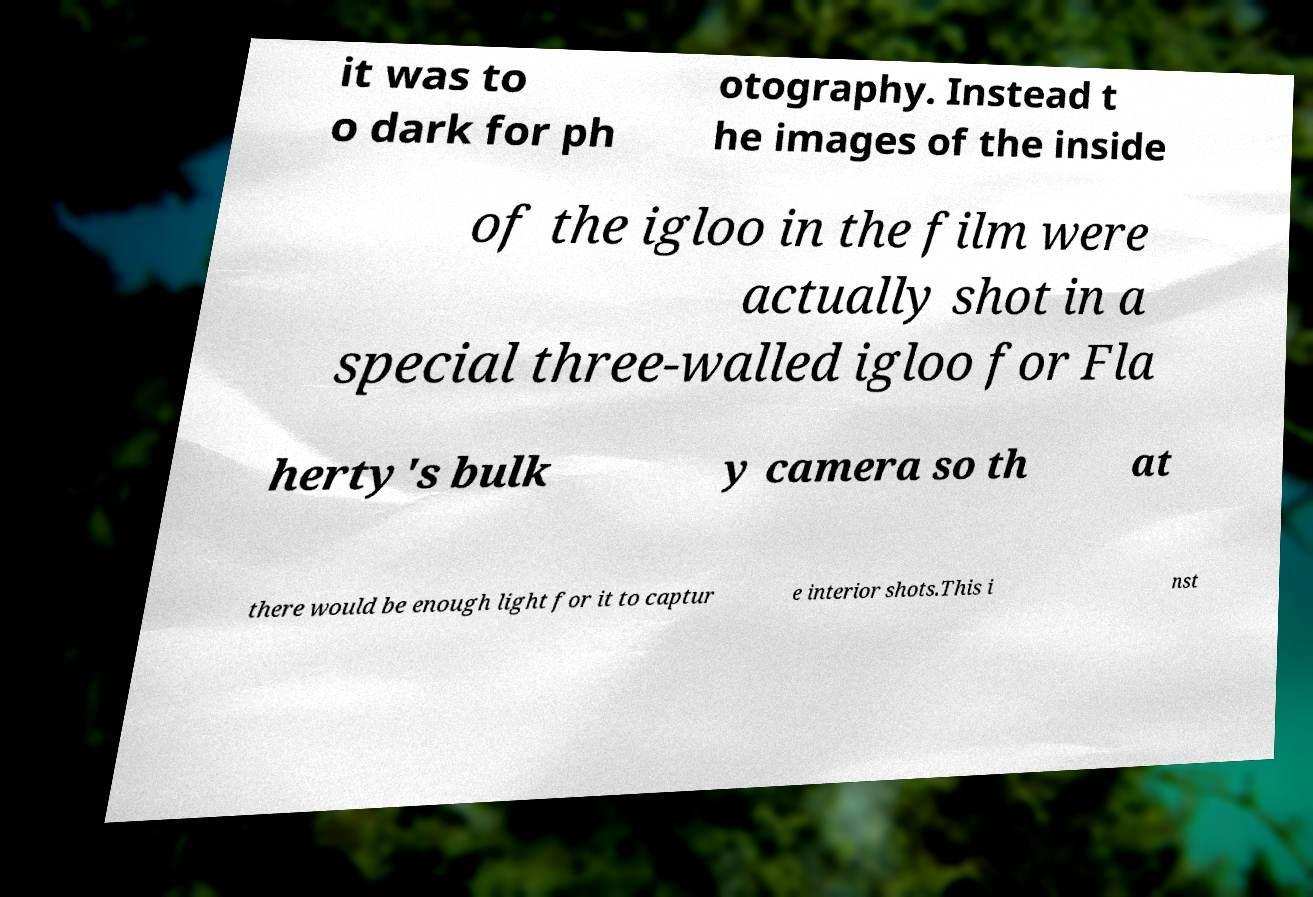Could you assist in decoding the text presented in this image and type it out clearly? it was to o dark for ph otography. Instead t he images of the inside of the igloo in the film were actually shot in a special three-walled igloo for Fla herty's bulk y camera so th at there would be enough light for it to captur e interior shots.This i nst 